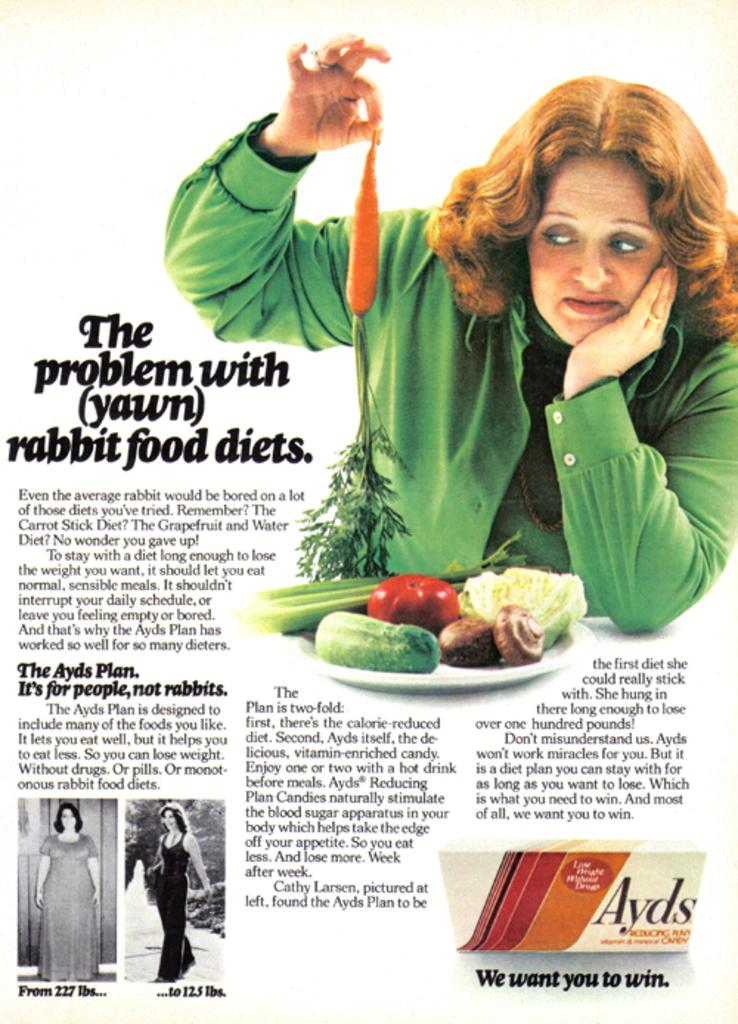<image>
Provide a brief description of the given image. Magazine page with the picture of three women and the article title The problem with rabbit food diets 